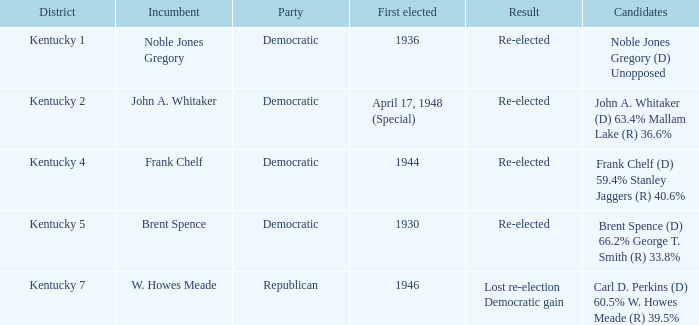How many times was the incumbent noble jones gregory first chosen? 1.0. 